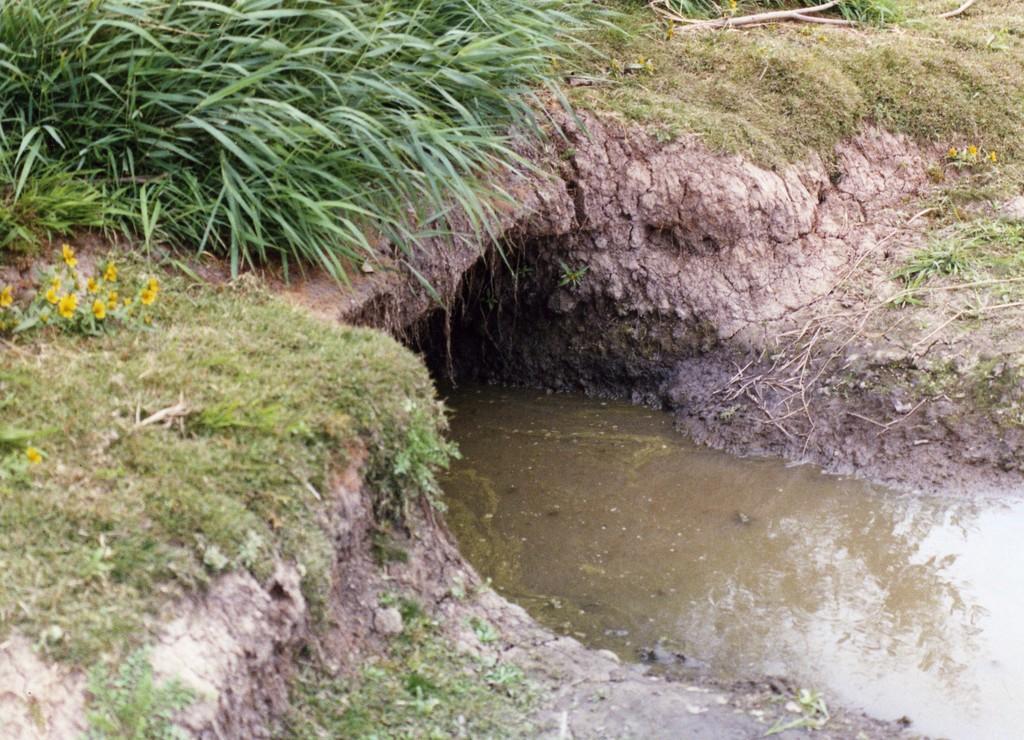Please provide a concise description of this image. In this image, we can see a canal. There are plants in the top right of the image. 